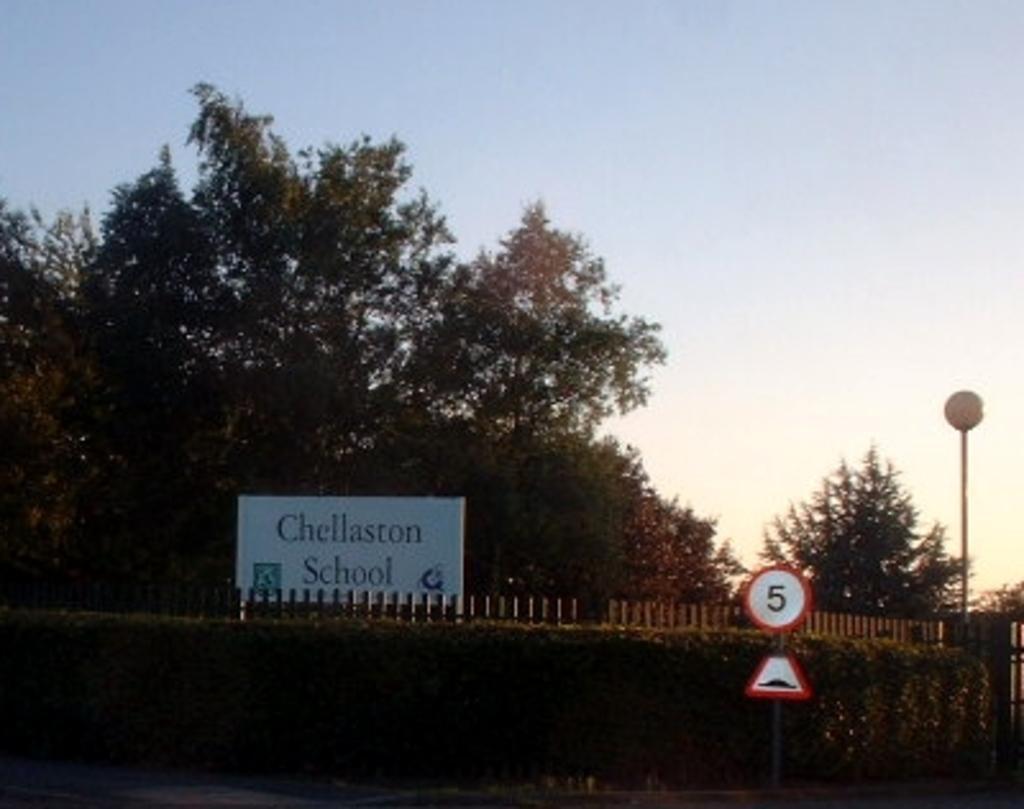Describe this image in one or two sentences. In this picture we can observe two boards fixed to this pole on the right side. There is a lamp fixed to the pole here. We can observe a white color poster. In the background there are trees and a sky. 